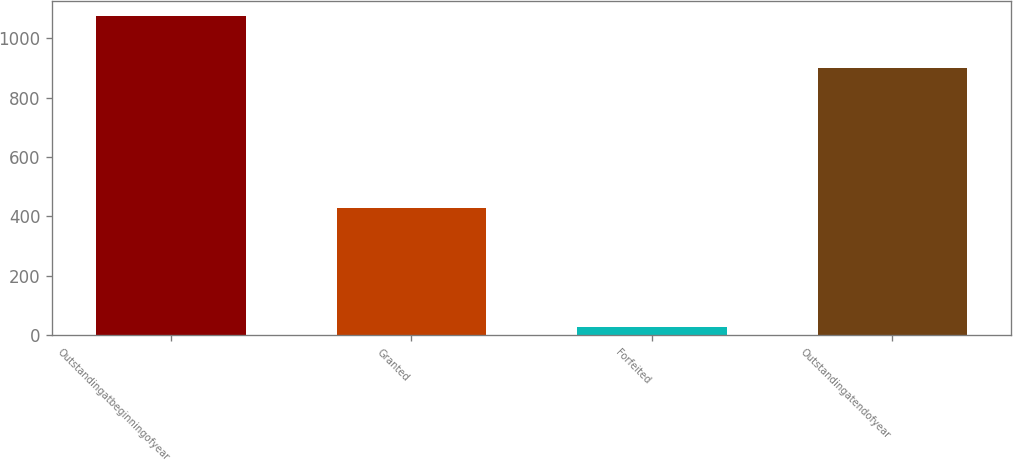Convert chart. <chart><loc_0><loc_0><loc_500><loc_500><bar_chart><fcel>Outstandingatbeginningofyear<fcel>Granted<fcel>Forfeited<fcel>Outstandingatendofyear<nl><fcel>1074<fcel>428<fcel>28<fcel>900<nl></chart> 